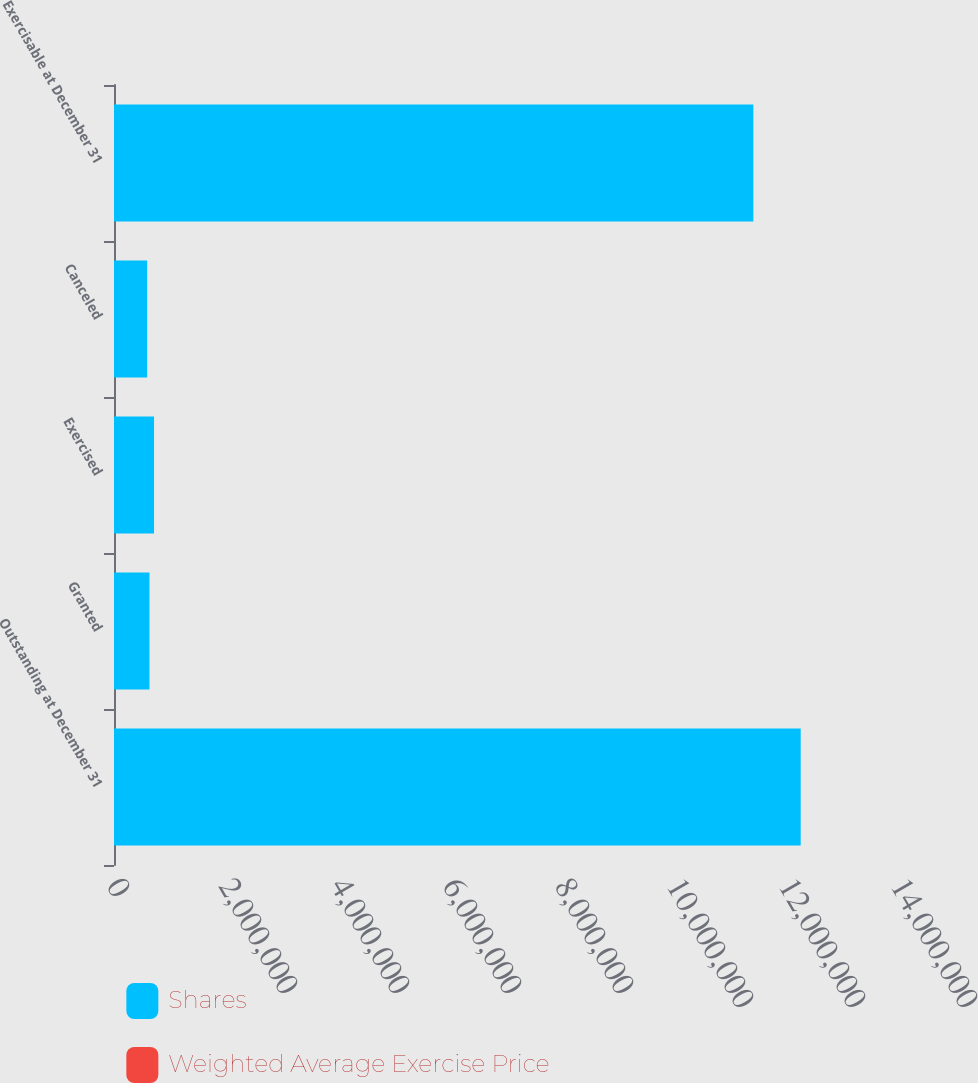Convert chart to OTSL. <chart><loc_0><loc_0><loc_500><loc_500><stacked_bar_chart><ecel><fcel>Outstanding at December 31<fcel>Granted<fcel>Exercised<fcel>Canceled<fcel>Exercisable at December 31<nl><fcel>Shares<fcel>1.22627e+07<fcel>633400<fcel>715143<fcel>592338<fcel>1.14168e+07<nl><fcel>Weighted Average Exercise Price<fcel>20.05<fcel>19.78<fcel>14.24<fcel>23.94<fcel>20.49<nl></chart> 